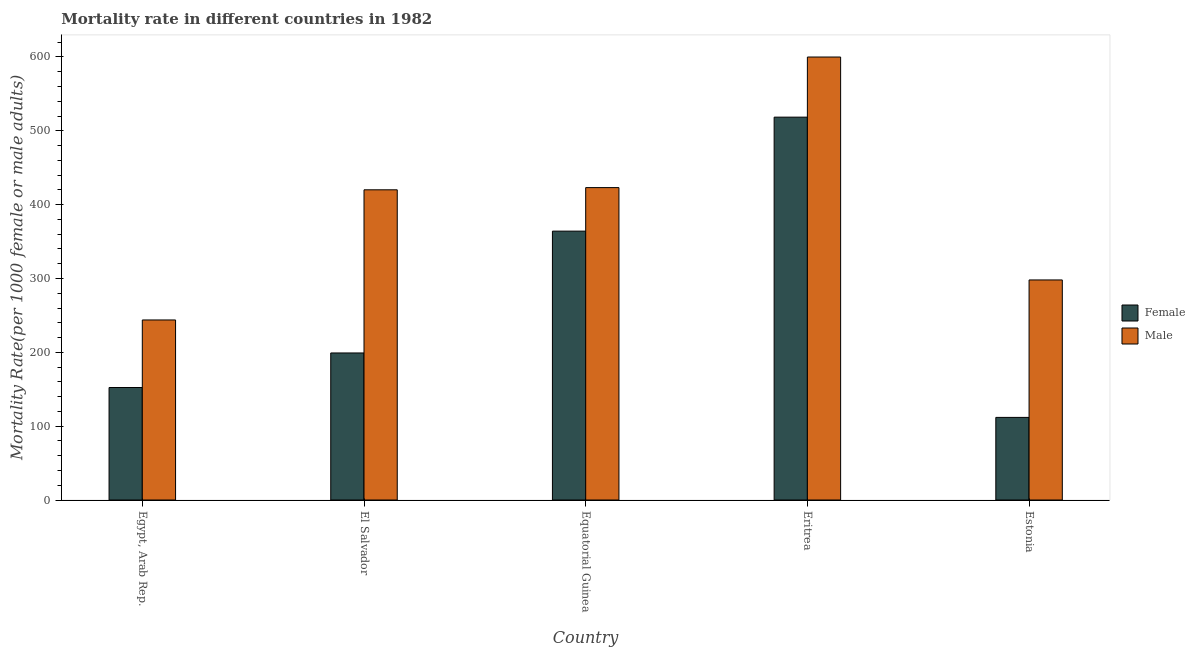How many different coloured bars are there?
Make the answer very short. 2. Are the number of bars per tick equal to the number of legend labels?
Provide a succinct answer. Yes. Are the number of bars on each tick of the X-axis equal?
Give a very brief answer. Yes. What is the label of the 2nd group of bars from the left?
Offer a terse response. El Salvador. What is the male mortality rate in Estonia?
Ensure brevity in your answer.  298. Across all countries, what is the maximum male mortality rate?
Offer a terse response. 599.87. Across all countries, what is the minimum female mortality rate?
Provide a succinct answer. 111.85. In which country was the male mortality rate maximum?
Offer a terse response. Eritrea. In which country was the female mortality rate minimum?
Keep it short and to the point. Estonia. What is the total male mortality rate in the graph?
Keep it short and to the point. 1984.77. What is the difference between the female mortality rate in Egypt, Arab Rep. and that in Eritrea?
Your answer should be very brief. -366.11. What is the difference between the male mortality rate in El Salvador and the female mortality rate in Eritrea?
Your answer should be very brief. -98.4. What is the average male mortality rate per country?
Provide a succinct answer. 396.95. What is the difference between the female mortality rate and male mortality rate in El Salvador?
Your answer should be very brief. -220.94. What is the ratio of the male mortality rate in Egypt, Arab Rep. to that in El Salvador?
Keep it short and to the point. 0.58. Is the difference between the male mortality rate in Eritrea and Estonia greater than the difference between the female mortality rate in Eritrea and Estonia?
Provide a short and direct response. No. What is the difference between the highest and the second highest male mortality rate?
Give a very brief answer. 176.83. What is the difference between the highest and the lowest female mortality rate?
Your response must be concise. 406.6. In how many countries, is the male mortality rate greater than the average male mortality rate taken over all countries?
Offer a very short reply. 3. What does the 1st bar from the left in Estonia represents?
Your answer should be very brief. Female. What does the 2nd bar from the right in Eritrea represents?
Offer a very short reply. Female. Are all the bars in the graph horizontal?
Ensure brevity in your answer.  No. How many countries are there in the graph?
Ensure brevity in your answer.  5. What is the difference between two consecutive major ticks on the Y-axis?
Give a very brief answer. 100. Does the graph contain grids?
Keep it short and to the point. No. How are the legend labels stacked?
Offer a terse response. Vertical. What is the title of the graph?
Provide a succinct answer. Mortality rate in different countries in 1982. What is the label or title of the Y-axis?
Ensure brevity in your answer.  Mortality Rate(per 1000 female or male adults). What is the Mortality Rate(per 1000 female or male adults) of Female in Egypt, Arab Rep.?
Your answer should be compact. 152.34. What is the Mortality Rate(per 1000 female or male adults) in Male in Egypt, Arab Rep.?
Offer a very short reply. 243.81. What is the Mortality Rate(per 1000 female or male adults) in Female in El Salvador?
Your answer should be compact. 199.12. What is the Mortality Rate(per 1000 female or male adults) in Male in El Salvador?
Your response must be concise. 420.06. What is the Mortality Rate(per 1000 female or male adults) in Female in Equatorial Guinea?
Your answer should be very brief. 364.09. What is the Mortality Rate(per 1000 female or male adults) of Male in Equatorial Guinea?
Offer a terse response. 423.04. What is the Mortality Rate(per 1000 female or male adults) in Female in Eritrea?
Offer a very short reply. 518.45. What is the Mortality Rate(per 1000 female or male adults) in Male in Eritrea?
Give a very brief answer. 599.87. What is the Mortality Rate(per 1000 female or male adults) in Female in Estonia?
Offer a very short reply. 111.85. What is the Mortality Rate(per 1000 female or male adults) of Male in Estonia?
Your answer should be very brief. 298. Across all countries, what is the maximum Mortality Rate(per 1000 female or male adults) of Female?
Your answer should be very brief. 518.45. Across all countries, what is the maximum Mortality Rate(per 1000 female or male adults) of Male?
Offer a terse response. 599.87. Across all countries, what is the minimum Mortality Rate(per 1000 female or male adults) of Female?
Ensure brevity in your answer.  111.85. Across all countries, what is the minimum Mortality Rate(per 1000 female or male adults) of Male?
Offer a terse response. 243.81. What is the total Mortality Rate(per 1000 female or male adults) of Female in the graph?
Your response must be concise. 1345.85. What is the total Mortality Rate(per 1000 female or male adults) in Male in the graph?
Your response must be concise. 1984.77. What is the difference between the Mortality Rate(per 1000 female or male adults) in Female in Egypt, Arab Rep. and that in El Salvador?
Offer a terse response. -46.78. What is the difference between the Mortality Rate(per 1000 female or male adults) of Male in Egypt, Arab Rep. and that in El Salvador?
Ensure brevity in your answer.  -176.25. What is the difference between the Mortality Rate(per 1000 female or male adults) in Female in Egypt, Arab Rep. and that in Equatorial Guinea?
Offer a very short reply. -211.75. What is the difference between the Mortality Rate(per 1000 female or male adults) in Male in Egypt, Arab Rep. and that in Equatorial Guinea?
Ensure brevity in your answer.  -179.23. What is the difference between the Mortality Rate(per 1000 female or male adults) of Female in Egypt, Arab Rep. and that in Eritrea?
Give a very brief answer. -366.11. What is the difference between the Mortality Rate(per 1000 female or male adults) of Male in Egypt, Arab Rep. and that in Eritrea?
Offer a very short reply. -356.06. What is the difference between the Mortality Rate(per 1000 female or male adults) in Female in Egypt, Arab Rep. and that in Estonia?
Provide a succinct answer. 40.49. What is the difference between the Mortality Rate(per 1000 female or male adults) in Male in Egypt, Arab Rep. and that in Estonia?
Keep it short and to the point. -54.19. What is the difference between the Mortality Rate(per 1000 female or male adults) of Female in El Salvador and that in Equatorial Guinea?
Give a very brief answer. -164.97. What is the difference between the Mortality Rate(per 1000 female or male adults) in Male in El Salvador and that in Equatorial Guinea?
Offer a terse response. -2.98. What is the difference between the Mortality Rate(per 1000 female or male adults) of Female in El Salvador and that in Eritrea?
Offer a terse response. -319.33. What is the difference between the Mortality Rate(per 1000 female or male adults) in Male in El Salvador and that in Eritrea?
Give a very brief answer. -179.81. What is the difference between the Mortality Rate(per 1000 female or male adults) of Female in El Salvador and that in Estonia?
Make the answer very short. 87.27. What is the difference between the Mortality Rate(per 1000 female or male adults) of Male in El Salvador and that in Estonia?
Provide a succinct answer. 122.06. What is the difference between the Mortality Rate(per 1000 female or male adults) in Female in Equatorial Guinea and that in Eritrea?
Ensure brevity in your answer.  -154.36. What is the difference between the Mortality Rate(per 1000 female or male adults) in Male in Equatorial Guinea and that in Eritrea?
Offer a very short reply. -176.84. What is the difference between the Mortality Rate(per 1000 female or male adults) in Female in Equatorial Guinea and that in Estonia?
Provide a succinct answer. 252.24. What is the difference between the Mortality Rate(per 1000 female or male adults) in Male in Equatorial Guinea and that in Estonia?
Provide a short and direct response. 125.04. What is the difference between the Mortality Rate(per 1000 female or male adults) of Female in Eritrea and that in Estonia?
Ensure brevity in your answer.  406.6. What is the difference between the Mortality Rate(per 1000 female or male adults) in Male in Eritrea and that in Estonia?
Ensure brevity in your answer.  301.87. What is the difference between the Mortality Rate(per 1000 female or male adults) in Female in Egypt, Arab Rep. and the Mortality Rate(per 1000 female or male adults) in Male in El Salvador?
Provide a short and direct response. -267.72. What is the difference between the Mortality Rate(per 1000 female or male adults) of Female in Egypt, Arab Rep. and the Mortality Rate(per 1000 female or male adults) of Male in Equatorial Guinea?
Ensure brevity in your answer.  -270.69. What is the difference between the Mortality Rate(per 1000 female or male adults) in Female in Egypt, Arab Rep. and the Mortality Rate(per 1000 female or male adults) in Male in Eritrea?
Your answer should be compact. -447.53. What is the difference between the Mortality Rate(per 1000 female or male adults) in Female in Egypt, Arab Rep. and the Mortality Rate(per 1000 female or male adults) in Male in Estonia?
Offer a terse response. -145.66. What is the difference between the Mortality Rate(per 1000 female or male adults) of Female in El Salvador and the Mortality Rate(per 1000 female or male adults) of Male in Equatorial Guinea?
Offer a terse response. -223.92. What is the difference between the Mortality Rate(per 1000 female or male adults) in Female in El Salvador and the Mortality Rate(per 1000 female or male adults) in Male in Eritrea?
Your answer should be very brief. -400.75. What is the difference between the Mortality Rate(per 1000 female or male adults) in Female in El Salvador and the Mortality Rate(per 1000 female or male adults) in Male in Estonia?
Provide a succinct answer. -98.88. What is the difference between the Mortality Rate(per 1000 female or male adults) in Female in Equatorial Guinea and the Mortality Rate(per 1000 female or male adults) in Male in Eritrea?
Ensure brevity in your answer.  -235.78. What is the difference between the Mortality Rate(per 1000 female or male adults) in Female in Equatorial Guinea and the Mortality Rate(per 1000 female or male adults) in Male in Estonia?
Provide a succinct answer. 66.09. What is the difference between the Mortality Rate(per 1000 female or male adults) in Female in Eritrea and the Mortality Rate(per 1000 female or male adults) in Male in Estonia?
Ensure brevity in your answer.  220.46. What is the average Mortality Rate(per 1000 female or male adults) of Female per country?
Offer a terse response. 269.17. What is the average Mortality Rate(per 1000 female or male adults) in Male per country?
Your answer should be very brief. 396.95. What is the difference between the Mortality Rate(per 1000 female or male adults) of Female and Mortality Rate(per 1000 female or male adults) of Male in Egypt, Arab Rep.?
Make the answer very short. -91.47. What is the difference between the Mortality Rate(per 1000 female or male adults) of Female and Mortality Rate(per 1000 female or male adults) of Male in El Salvador?
Provide a short and direct response. -220.94. What is the difference between the Mortality Rate(per 1000 female or male adults) in Female and Mortality Rate(per 1000 female or male adults) in Male in Equatorial Guinea?
Make the answer very short. -58.95. What is the difference between the Mortality Rate(per 1000 female or male adults) in Female and Mortality Rate(per 1000 female or male adults) in Male in Eritrea?
Your answer should be very brief. -81.42. What is the difference between the Mortality Rate(per 1000 female or male adults) of Female and Mortality Rate(per 1000 female or male adults) of Male in Estonia?
Offer a very short reply. -186.15. What is the ratio of the Mortality Rate(per 1000 female or male adults) of Female in Egypt, Arab Rep. to that in El Salvador?
Ensure brevity in your answer.  0.77. What is the ratio of the Mortality Rate(per 1000 female or male adults) in Male in Egypt, Arab Rep. to that in El Salvador?
Offer a terse response. 0.58. What is the ratio of the Mortality Rate(per 1000 female or male adults) of Female in Egypt, Arab Rep. to that in Equatorial Guinea?
Your answer should be compact. 0.42. What is the ratio of the Mortality Rate(per 1000 female or male adults) of Male in Egypt, Arab Rep. to that in Equatorial Guinea?
Offer a terse response. 0.58. What is the ratio of the Mortality Rate(per 1000 female or male adults) of Female in Egypt, Arab Rep. to that in Eritrea?
Provide a succinct answer. 0.29. What is the ratio of the Mortality Rate(per 1000 female or male adults) in Male in Egypt, Arab Rep. to that in Eritrea?
Provide a succinct answer. 0.41. What is the ratio of the Mortality Rate(per 1000 female or male adults) of Female in Egypt, Arab Rep. to that in Estonia?
Keep it short and to the point. 1.36. What is the ratio of the Mortality Rate(per 1000 female or male adults) in Male in Egypt, Arab Rep. to that in Estonia?
Offer a very short reply. 0.82. What is the ratio of the Mortality Rate(per 1000 female or male adults) of Female in El Salvador to that in Equatorial Guinea?
Ensure brevity in your answer.  0.55. What is the ratio of the Mortality Rate(per 1000 female or male adults) in Male in El Salvador to that in Equatorial Guinea?
Offer a terse response. 0.99. What is the ratio of the Mortality Rate(per 1000 female or male adults) in Female in El Salvador to that in Eritrea?
Offer a terse response. 0.38. What is the ratio of the Mortality Rate(per 1000 female or male adults) in Male in El Salvador to that in Eritrea?
Your response must be concise. 0.7. What is the ratio of the Mortality Rate(per 1000 female or male adults) of Female in El Salvador to that in Estonia?
Offer a very short reply. 1.78. What is the ratio of the Mortality Rate(per 1000 female or male adults) of Male in El Salvador to that in Estonia?
Provide a short and direct response. 1.41. What is the ratio of the Mortality Rate(per 1000 female or male adults) in Female in Equatorial Guinea to that in Eritrea?
Ensure brevity in your answer.  0.7. What is the ratio of the Mortality Rate(per 1000 female or male adults) of Male in Equatorial Guinea to that in Eritrea?
Make the answer very short. 0.71. What is the ratio of the Mortality Rate(per 1000 female or male adults) in Female in Equatorial Guinea to that in Estonia?
Keep it short and to the point. 3.26. What is the ratio of the Mortality Rate(per 1000 female or male adults) in Male in Equatorial Guinea to that in Estonia?
Provide a short and direct response. 1.42. What is the ratio of the Mortality Rate(per 1000 female or male adults) in Female in Eritrea to that in Estonia?
Provide a succinct answer. 4.64. What is the ratio of the Mortality Rate(per 1000 female or male adults) of Male in Eritrea to that in Estonia?
Your answer should be very brief. 2.01. What is the difference between the highest and the second highest Mortality Rate(per 1000 female or male adults) of Female?
Make the answer very short. 154.36. What is the difference between the highest and the second highest Mortality Rate(per 1000 female or male adults) of Male?
Your answer should be compact. 176.84. What is the difference between the highest and the lowest Mortality Rate(per 1000 female or male adults) in Female?
Make the answer very short. 406.6. What is the difference between the highest and the lowest Mortality Rate(per 1000 female or male adults) of Male?
Provide a succinct answer. 356.06. 